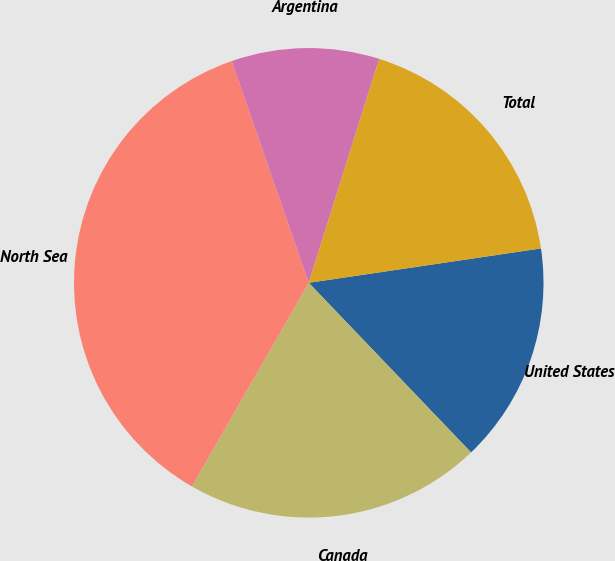Convert chart. <chart><loc_0><loc_0><loc_500><loc_500><pie_chart><fcel>United States<fcel>Canada<fcel>North Sea<fcel>Argentina<fcel>Total<nl><fcel>15.19%<fcel>20.44%<fcel>36.39%<fcel>10.17%<fcel>17.81%<nl></chart> 